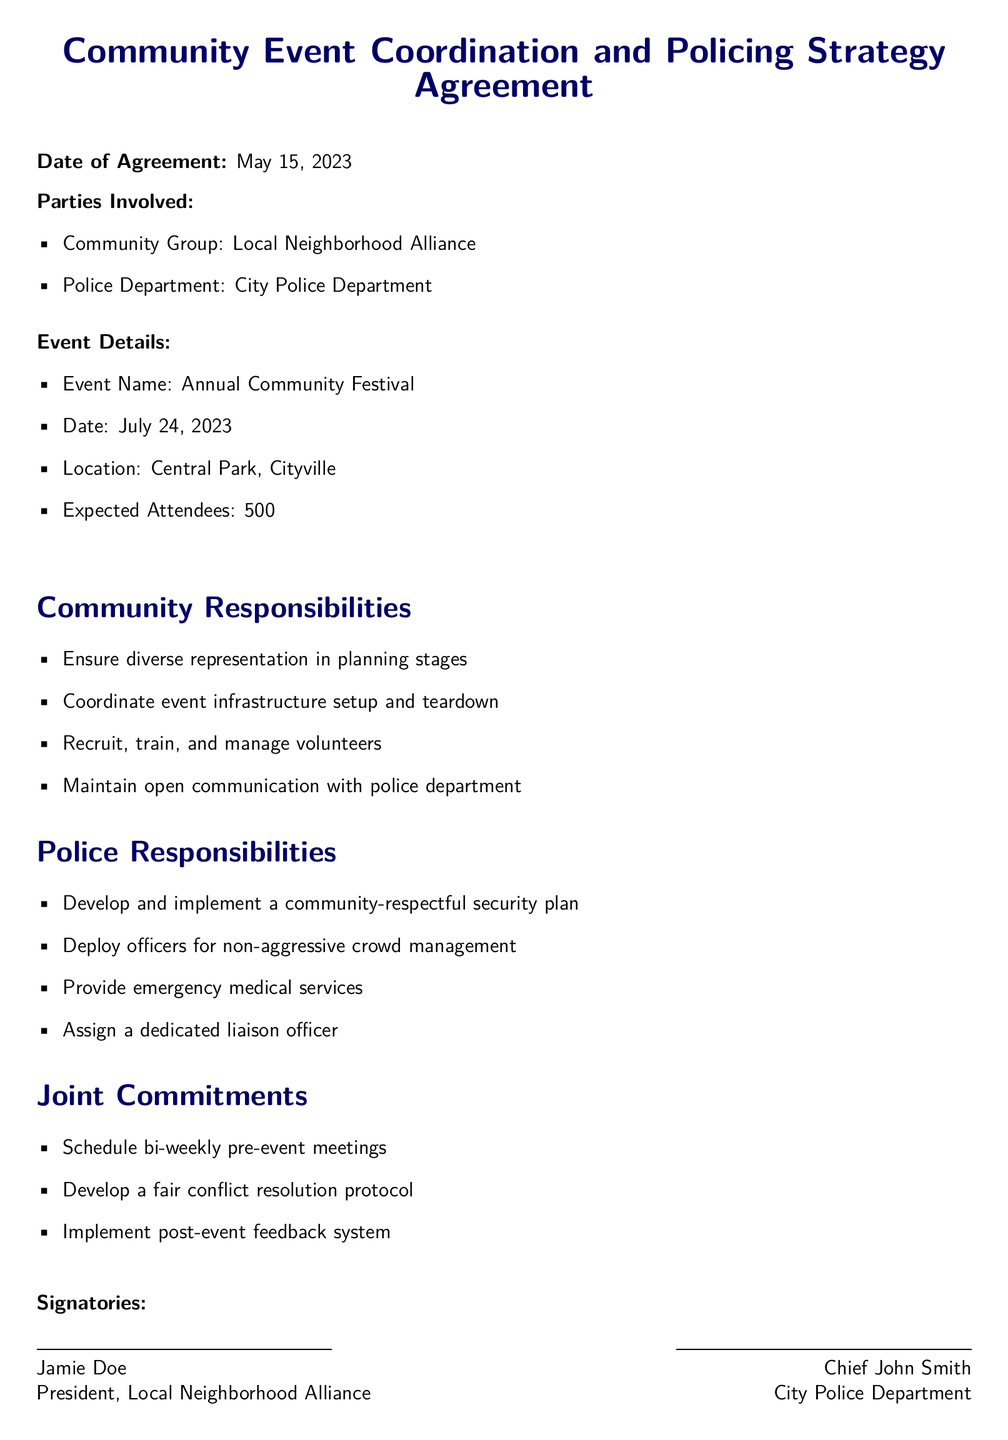What is the date of the agreement? The date of the agreement is explicitly stated at the top of the document.
Answer: May 15, 2023 Who are the parties involved? The parties involved are listed in a clear format in the document.
Answer: Local Neighborhood Alliance and City Police Department What is the name of the event? The event name is mentioned in the "Event Details" section of the document.
Answer: Annual Community Festival How many expected attendees are there? The expected number of attendees is specified in the event details section.
Answer: 500 What is one responsibility of the police? The police responsibilities section outlines several tasks for the police department.
Answer: Develop and implement a community-respectful security plan What is one responsibility of the community group? The community responsibilities section outlines tasks for the community group.
Answer: Ensure diverse representation in planning stages How often are the pre-event meetings scheduled? The frequency of the pre-event meetings is noted in the joint commitments section.
Answer: Bi-weekly What does the joint commitment include regarding feedback? The joint commitments outline specific agreements that include a feedback mechanism.
Answer: Implement post-event feedback system Who signed the document on behalf of the community group? The signatories are noted at the end of the document.
Answer: Jamie Doe Who is the chief of the police department? The signatories at the end of the document identify the police chief.
Answer: Chief John Smith 